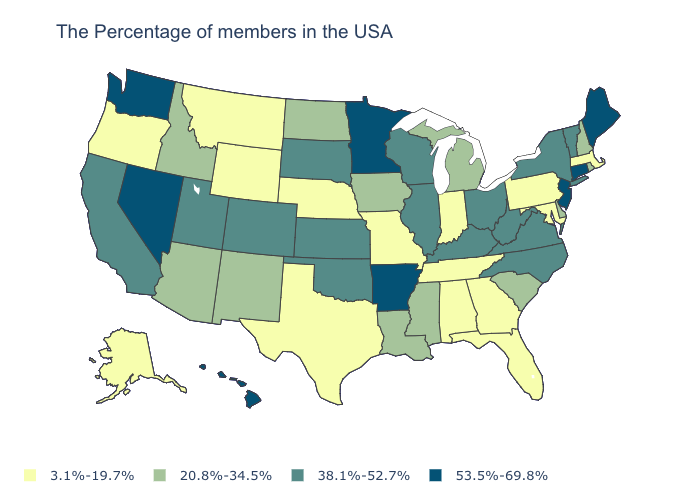How many symbols are there in the legend?
Concise answer only. 4. What is the highest value in states that border Montana?
Be succinct. 38.1%-52.7%. What is the value of Montana?
Keep it brief. 3.1%-19.7%. Does New Mexico have the same value as Nevada?
Concise answer only. No. What is the value of Wisconsin?
Write a very short answer. 38.1%-52.7%. What is the value of New Jersey?
Give a very brief answer. 53.5%-69.8%. Does Vermont have the highest value in the USA?
Quick response, please. No. Does Nebraska have the highest value in the MidWest?
Give a very brief answer. No. Does Rhode Island have the same value as Alabama?
Quick response, please. No. What is the highest value in the South ?
Short answer required. 53.5%-69.8%. Name the states that have a value in the range 3.1%-19.7%?
Keep it brief. Massachusetts, Maryland, Pennsylvania, Florida, Georgia, Indiana, Alabama, Tennessee, Missouri, Nebraska, Texas, Wyoming, Montana, Oregon, Alaska. What is the value of Mississippi?
Quick response, please. 20.8%-34.5%. Among the states that border Massachusetts , does Rhode Island have the lowest value?
Give a very brief answer. Yes. Which states hav the highest value in the South?
Answer briefly. Arkansas. What is the lowest value in the Northeast?
Be succinct. 3.1%-19.7%. 